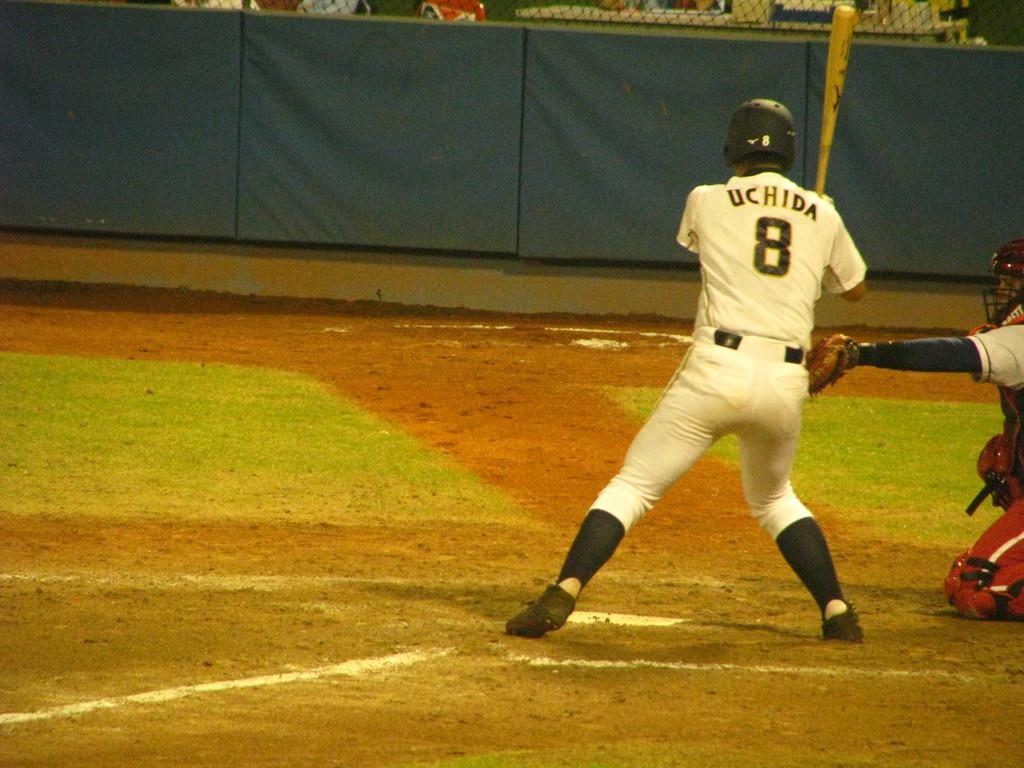<image>
Offer a succinct explanation of the picture presented. A man playing baseball has UCHIDA on the back of his shirt. 